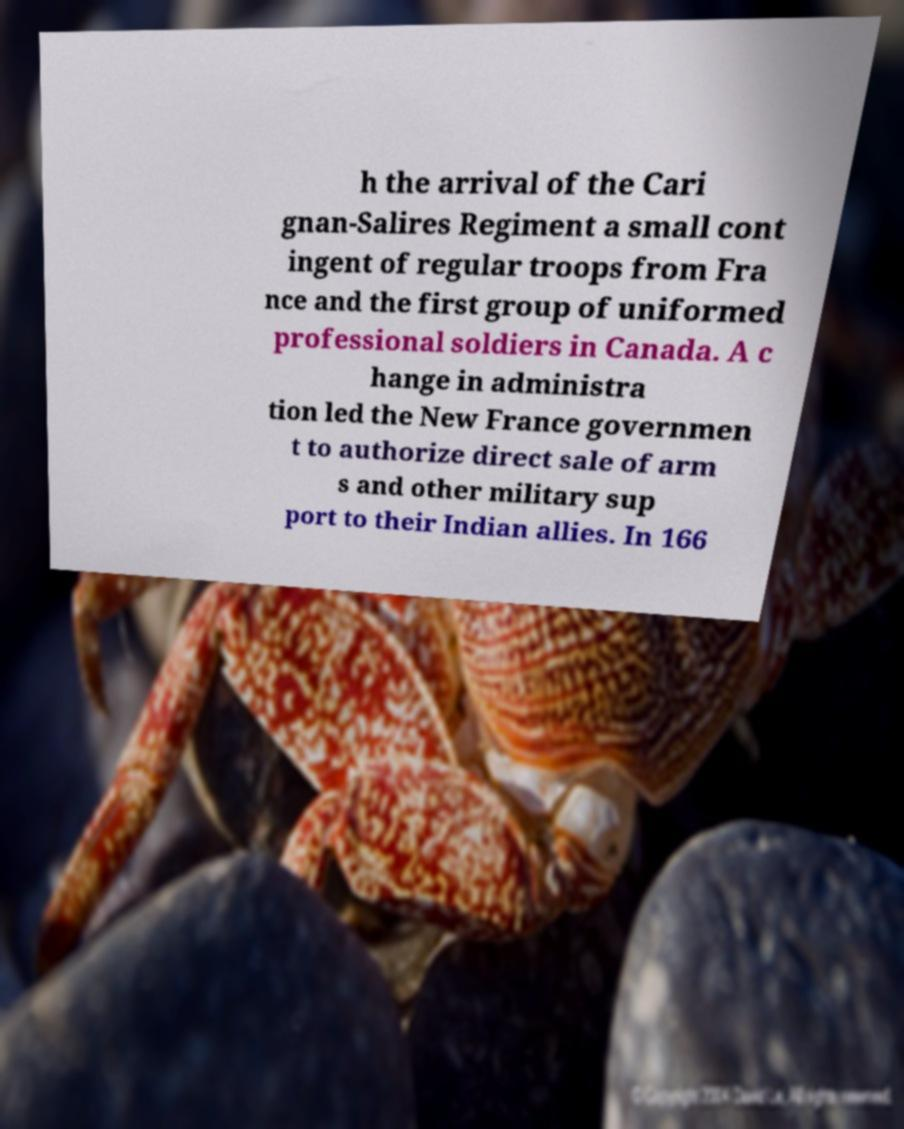For documentation purposes, I need the text within this image transcribed. Could you provide that? h the arrival of the Cari gnan-Salires Regiment a small cont ingent of regular troops from Fra nce and the first group of uniformed professional soldiers in Canada. A c hange in administra tion led the New France governmen t to authorize direct sale of arm s and other military sup port to their Indian allies. In 166 